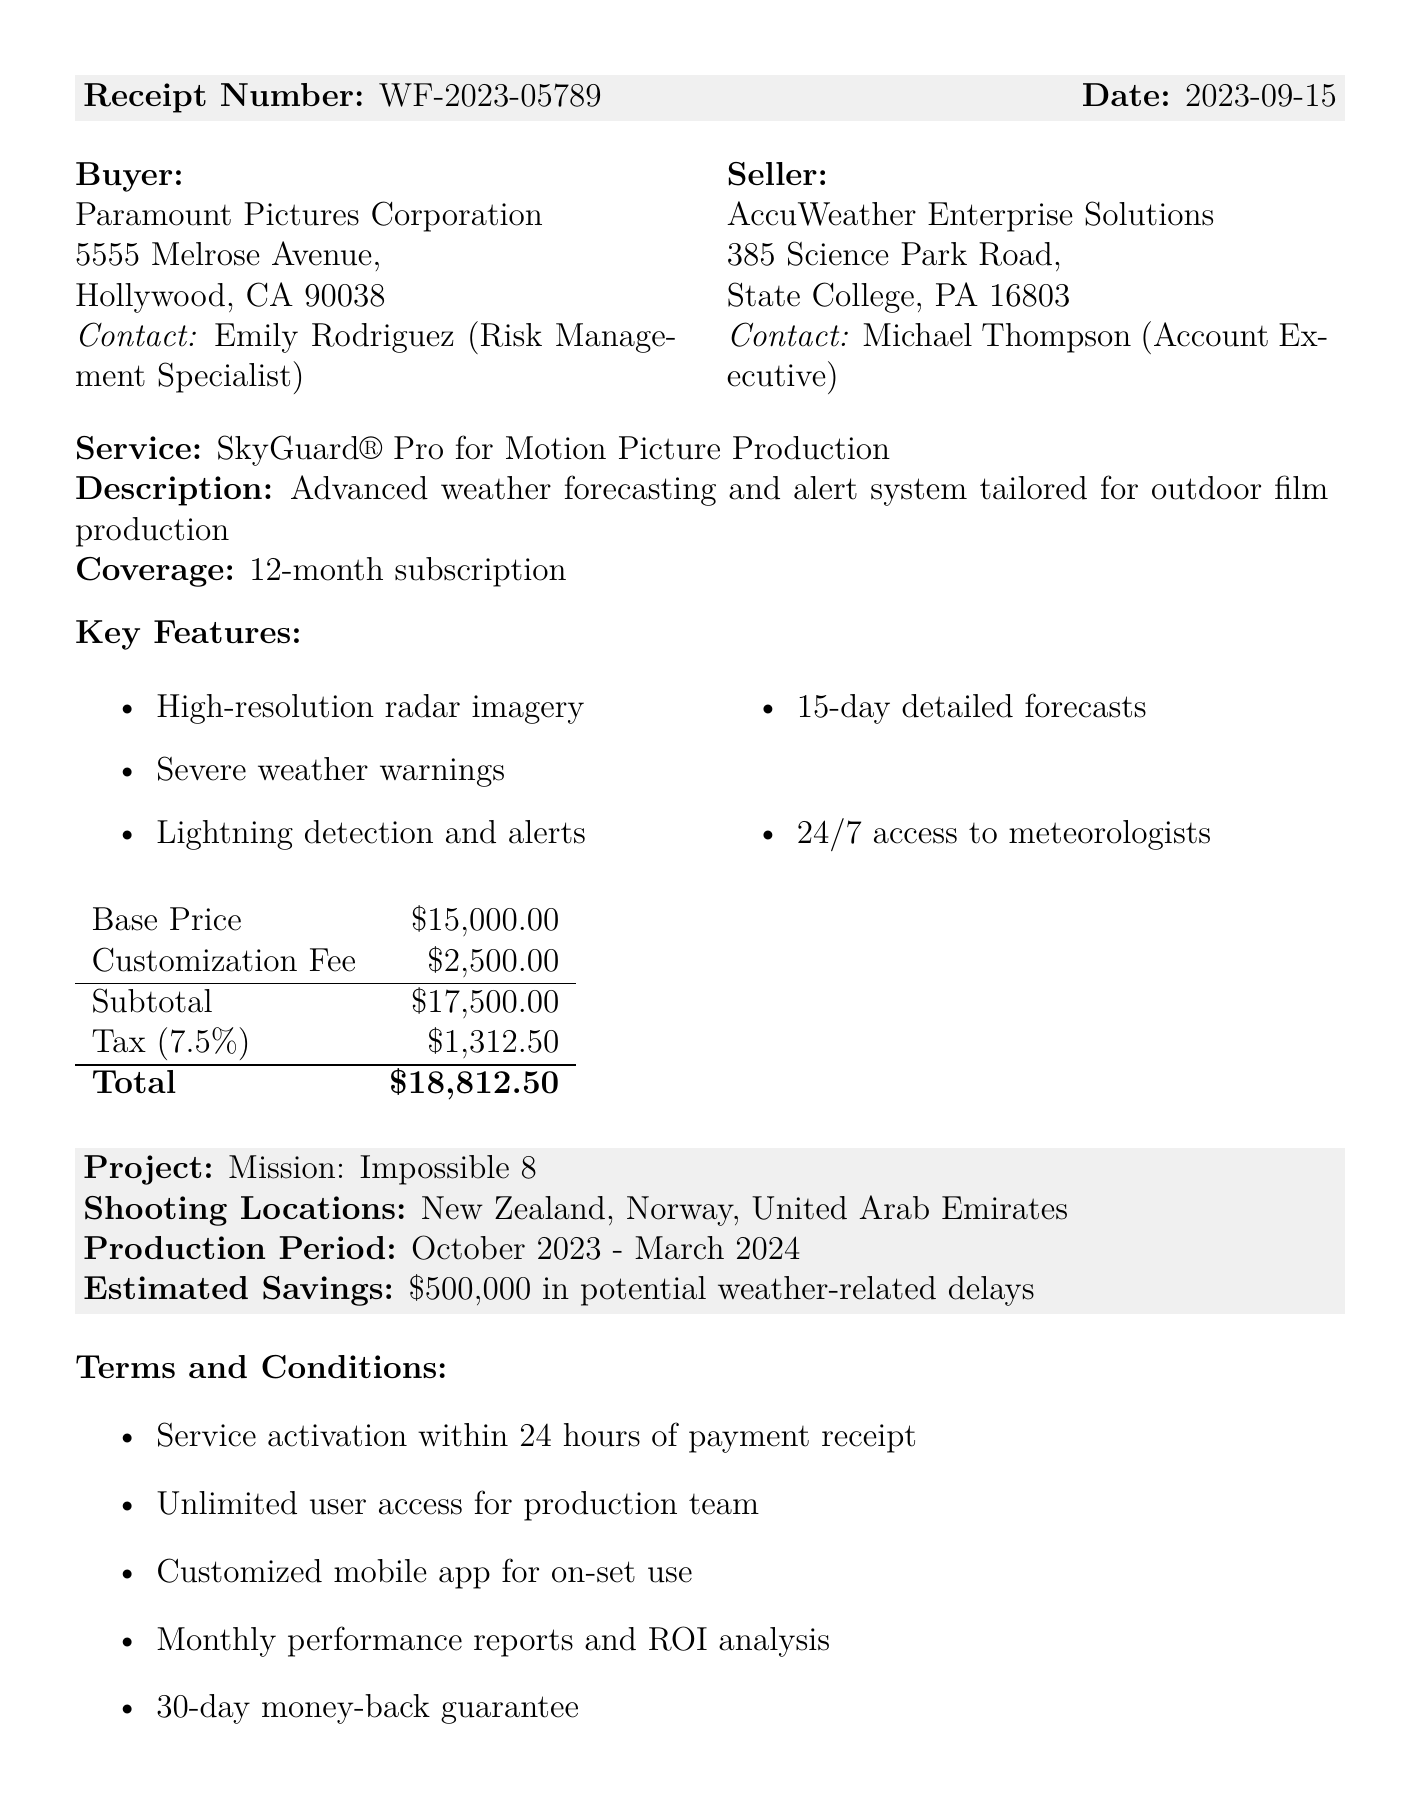What is the receipt number? The receipt number is listed in the document under transaction details.
Answer: WF-2023-05789 What is the total amount paid? The total amount is the final sum shown in the pricing section of the document.
Answer: $18,812.50 Who is the contact person for the buyer? The contact person’s name and position for the buyer is mentioned in the buyer section.
Answer: Emily Rodriguez What is the service name purchased? The service name is stated in the service details section.
Answer: SkyGuard® Pro for Motion Picture Production What are the shooting locations? The shooting locations are specified in the additional information section.
Answer: New Zealand, Norway, United Arab Emirates What is the estimated savings mentioned? The estimated savings can be found in the additional information section of the document.
Answer: $500,000 in potential weather-related delays How long is the subscription period? The subscription period is indicated in the service details section.
Answer: 12-month subscription When was the payment receipt generated? The date of the payment receipt is provided in the transaction details.
Answer: 2023-09-15 Who is the seller's contact person? The seller's contact person is named in the seller section of the document.
Answer: Michael Thompson 